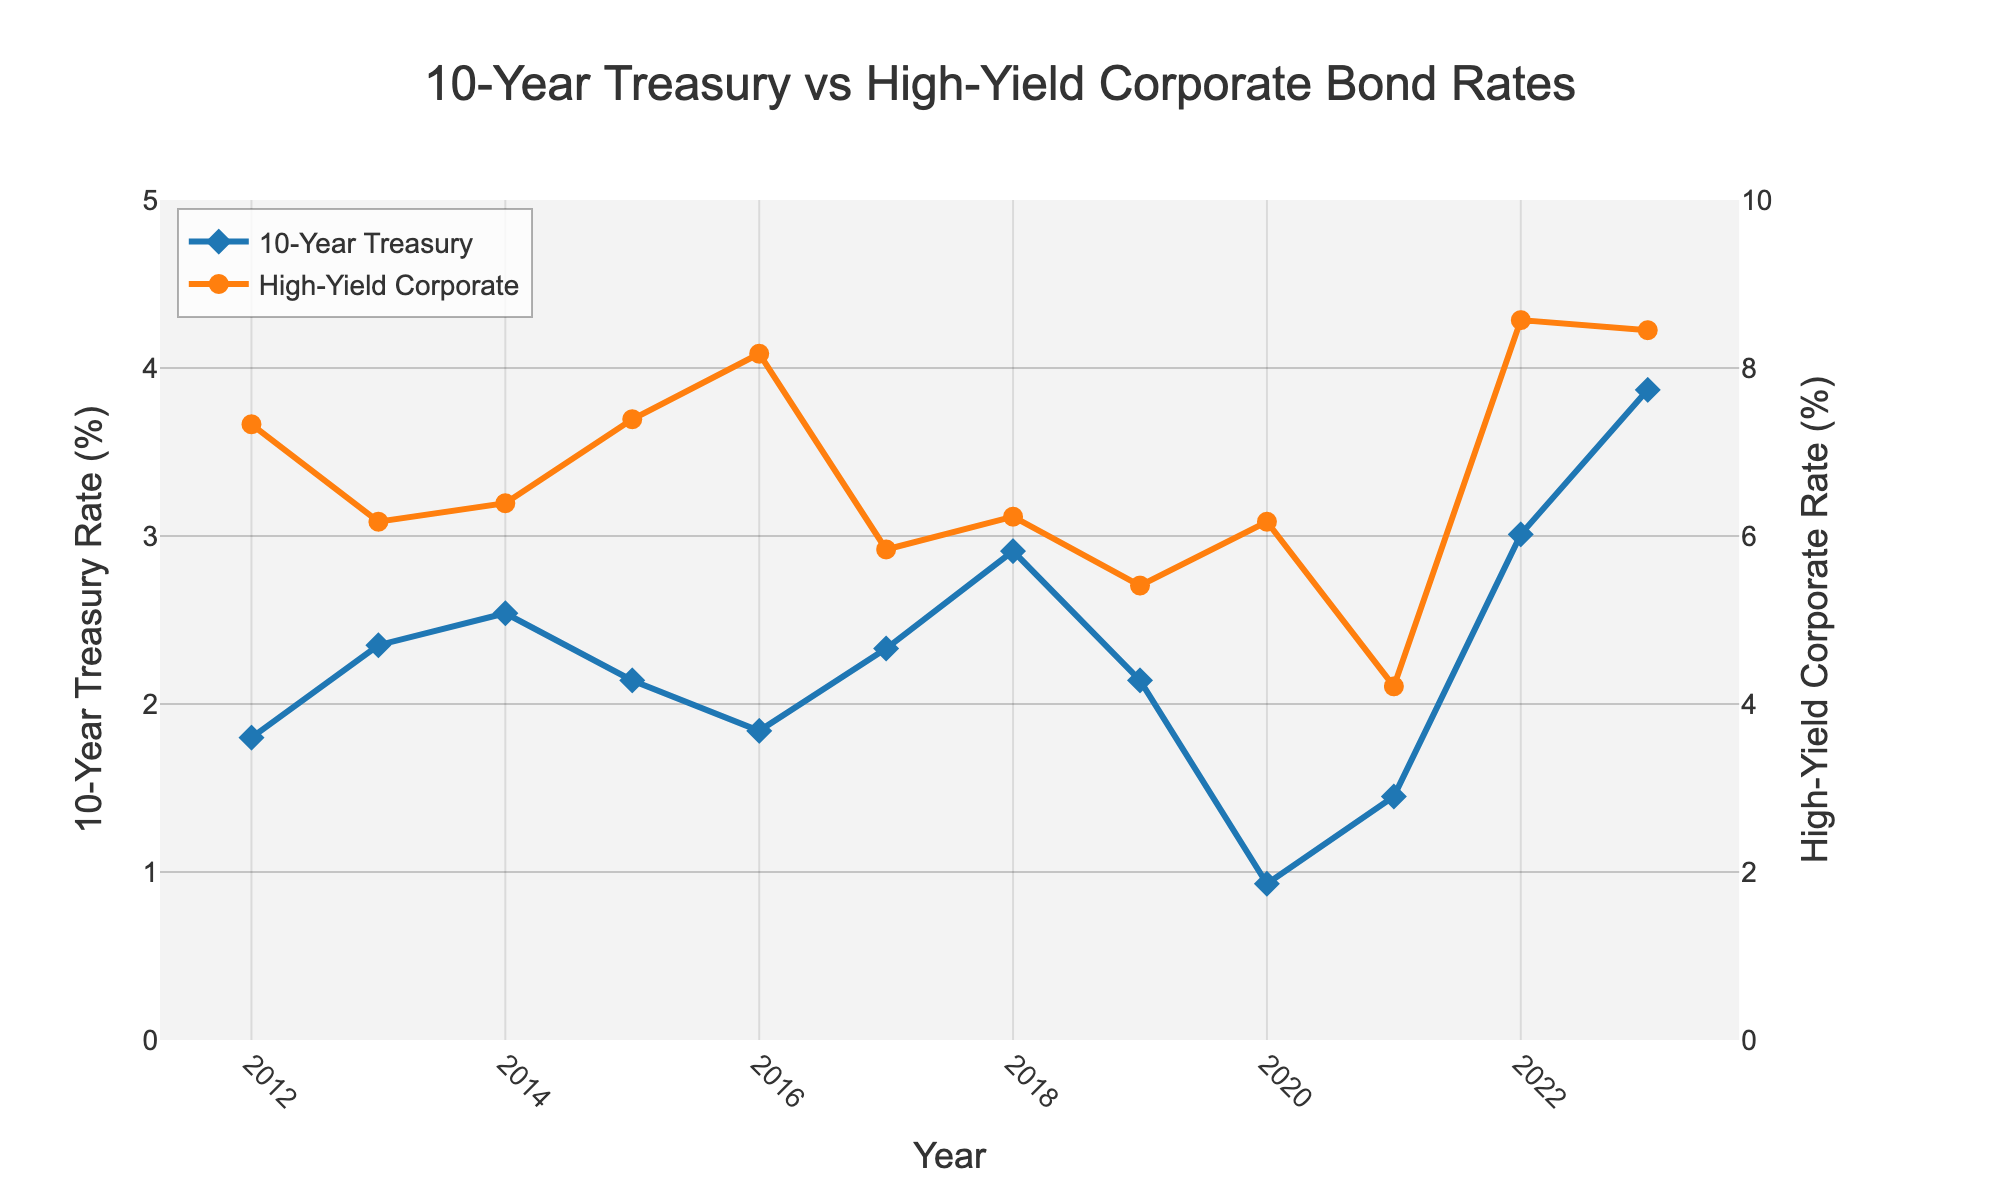What was the interest rate for the 10-Year Treasury bond in 2020? Look at the point for the year 2020 on the line representing the 10-Year Treasury bond. The corresponding interest rate is marked.
Answer: 0.93% Which year had the highest interest rate for high-yield corporate bonds? Identify the highest point on the line representing high-yield corporate bonds and find its corresponding year. The highest point is in 2022.
Answer: 2022 What is the average interest rate for the 10-Year Treasury bond over the period 2012-2023? Sum all the 10-Year Treasury rates from 2012 to 2023 and divide by the number of years. (1.80 + 2.35 + 2.54 + 2.14 + 1.84 + 2.33 + 2.91 + 2.14 + 0.93 + 1.45 + 3.01 + 3.87) / 12 ≈ 2.21
Answer: 2.21% Identify the year with the smallest gap between the 10-Year Treasury bond rate and the high-yield corporate bond rate. Calculate the absolute difference between the two rates for each year and identify the smallest difference: 
2012: 5.53, 2013: 3.82, 2014: 3.85, 2015: 5.25, 2016: 6.33, 2017: 3.51, 2018: 3.32, 2019: 3.27, 2020: 5.24, 2021: 2.76, 2022: 5.56, 2023: 4.58
The smallest gap is in 2021.
Answer: 2021 Which bond type had a more volatile interest rate, based on visual inspection of the plot? Observe the lines for each type. The high-yield corporate bond line shows larger fluctuations and changes more drastically compared to the relatively stable 10-Year Treasury bond line.
Answer: High-Yield Corporate Bond Between which two consecutive years did the 10-Year Treasury bond rate decrease the most? Calculate the difference between consecutive years for the 10-Year Treasury bond rate and find the largest decrease: 
2012-13: -0.55, 2013-14: -0.19, 2014-15: +0.40, 2015-16: +0.30, 2016-17: -0.49, 2017-18: -0.58, 2018-19: +0.77, 2019-20: -1.21, 2020-21: -0.52, 2021-22: +1.56, 2022-23: +0.86 
The largest decrease is between 2019 and 2020.
Answer: 2019-2020 What is the biggest difference between the high-yield corporate bond rate and the 10-Year Treasury bond rate in any given year within the dataset? Calculate the differences between the rates for each year, then identify the largest difference: 
2012: 5.53, 2013: 3.82, 2014: 3.85, 2015: 5.25, 2016: 6.33, 2017: 3.51, 2018: 3.32, 2019: 3.27, 2020: 5.24, 2021: 2.76, 2022: 5.56, 2023: 4.58
The biggest difference is in 2016.
Answer: 2016 During which years did the interest rates for both the 10-Year Treasury bond and the high-yield corporate bond increase? Examine the lines for both bonds and identify years where both rates increased: 
From 2012 to 2013 both increased, and from 2021 to 2022 both increased. Therefore, those years are 2013 and 2022.
Answer: 2013, 2022 